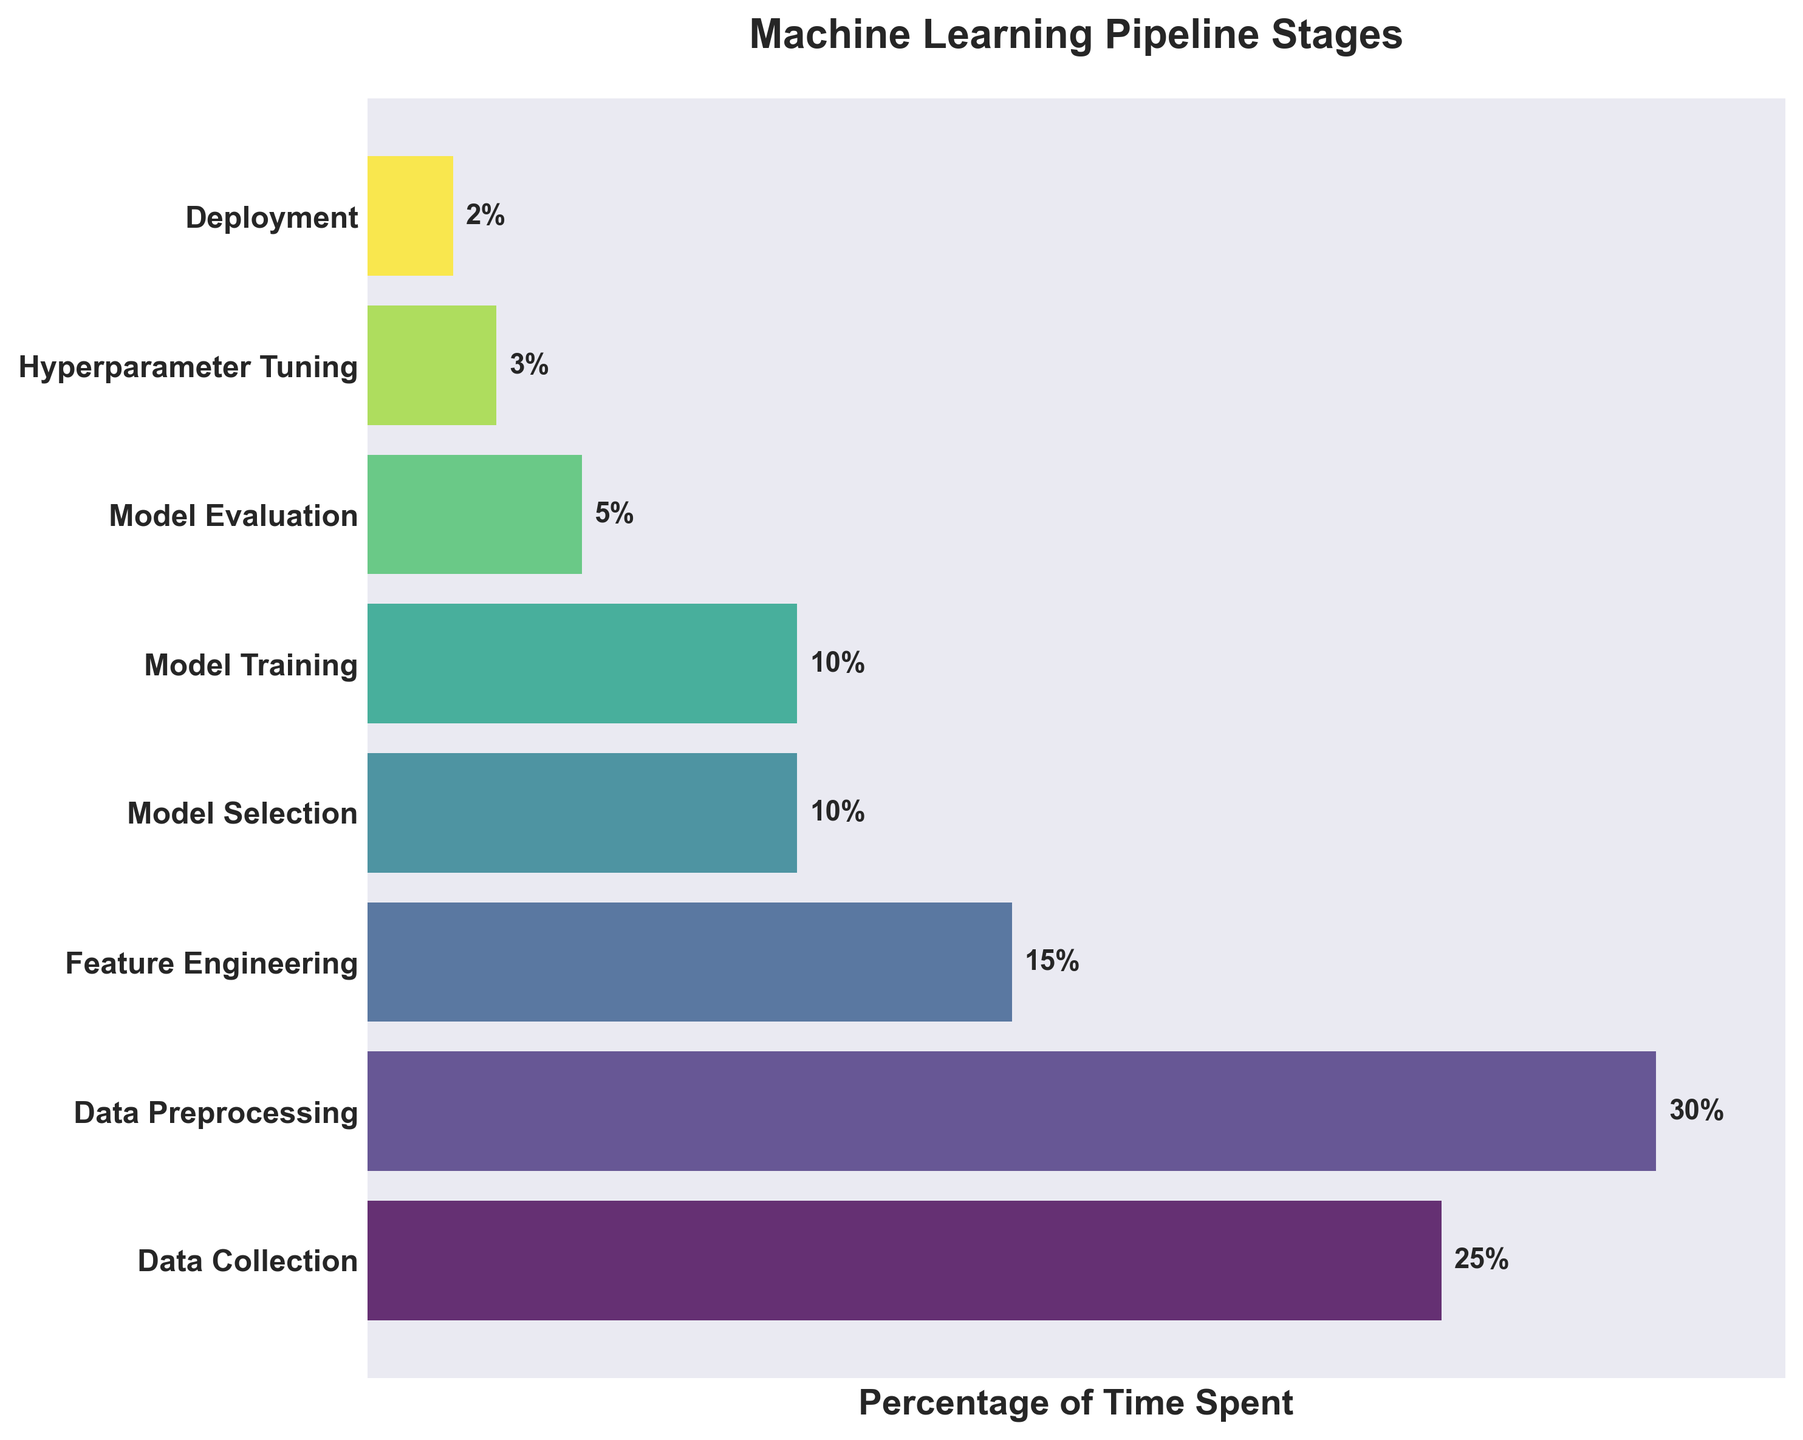what is the title of the figure? The title of the figure is located at the top and provides a summary of what the chart represents. According to the code, the title is "Machine Learning Pipeline Stages".
Answer: Machine Learning Pipeline Stages Which stage takes the most time in the pipeline? To find the stage that takes the most time, look for the largest bar in the funnel chart. According to the data, "Data Preprocessing" has the highest percentage (30%).
Answer: Data Preprocessing What percentage of time is spent on Model Training? Look at the label next to the bar representing "Model Training". According to the data, the percentage is displayed as "10%".
Answer: 10% How much more time is spent on Data Collection compared to Deployment? To find this, subtract the percentage for Deployment from the percentage for Data Collection. Data Collection is 25%, and Deployment is 2%. So, 25% - 2% = 23%.
Answer: 23% Is there any stage that takes less than 5% of the time? Look at the percentages for each stage and identify any that are less than 5%. According to the data, "Hyperparameter Tuning" and "Deployment" both take less than 5% of the time (3% and 2% respectively).
Answer: Yes What is the combined time spent on Hyperparameter Tuning and Deployment? To find the combined time, add the percentages for Hyperparameter Tuning and Deployment. Hyperparameter Tuning is 3%, and Deployment is 2%. So, 3% + 2% = 5%.
Answer: 5% Which stage takes the least amount of time? To find the stage that takes the least time, look for the smallest bar in the funnel chart. According to the data, "Deployment" has the lowest percentage (2%).
Answer: Deployment How does the time spent on Model Evaluation compare to Feature Engineering? To compare these, subtract the percentage for Model Evaluation from the percentage for Feature Engineering. Feature Engineering is 15%, and Model Evaluation is 5%. So, 15% - 5% = 10%.
Answer: 10% What stages take up a total of 40% of the time together? Look for combinations of stages that add up to 40%. For example, "Data Preprocessing" (30%) combined with "Model Training" (10%) gives 30% + 10% = 40%.
Answer: Data Preprocessing and Model Training 